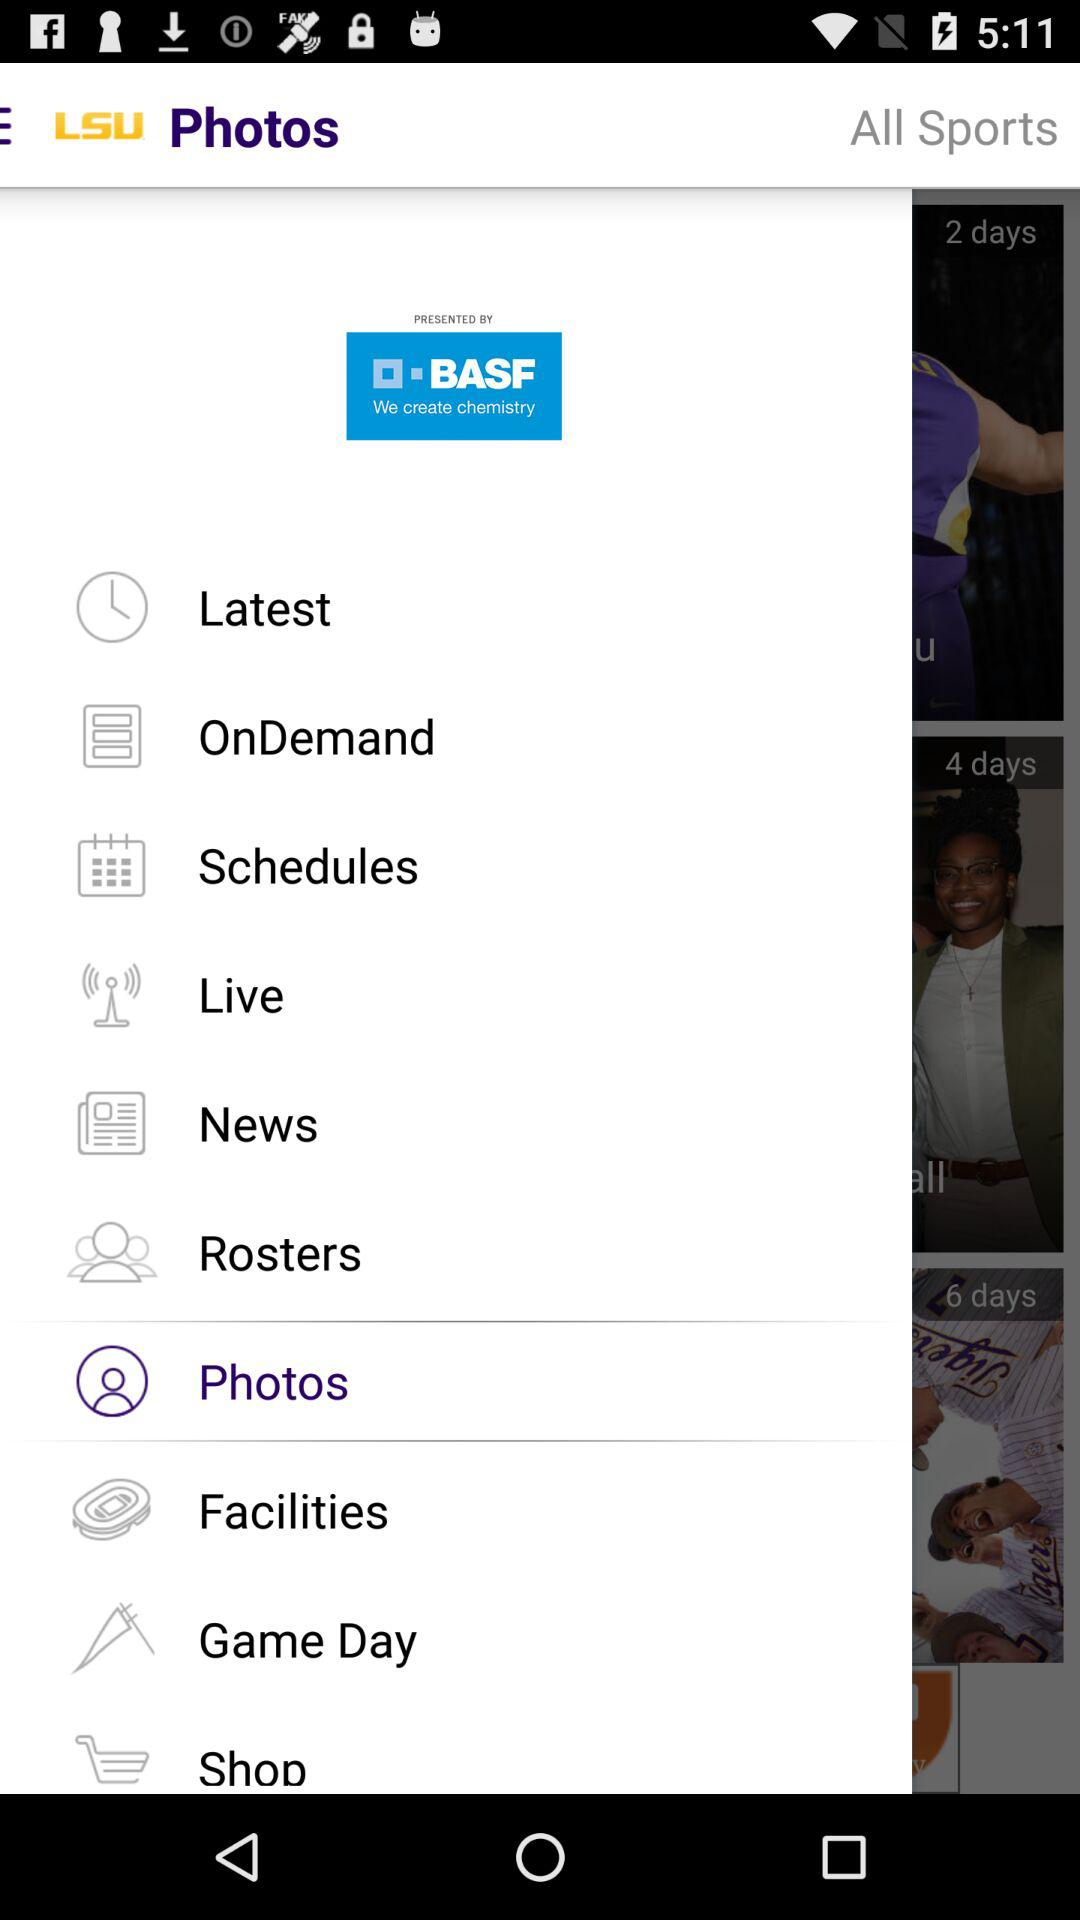By whom is "LSU" presented? "LSU" is presented by BASF. 